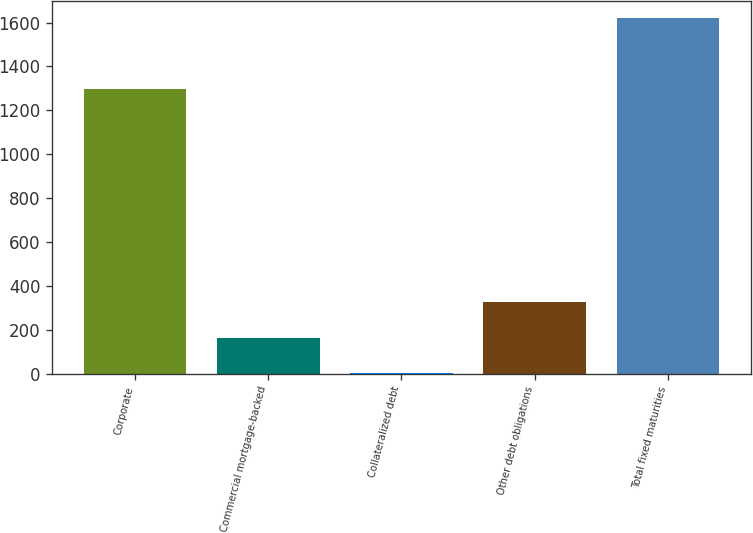<chart> <loc_0><loc_0><loc_500><loc_500><bar_chart><fcel>Corporate<fcel>Commercial mortgage-backed<fcel>Collateralized debt<fcel>Other debt obligations<fcel>Total fixed maturities<nl><fcel>1296.8<fcel>163.5<fcel>1.8<fcel>325.2<fcel>1618.8<nl></chart> 